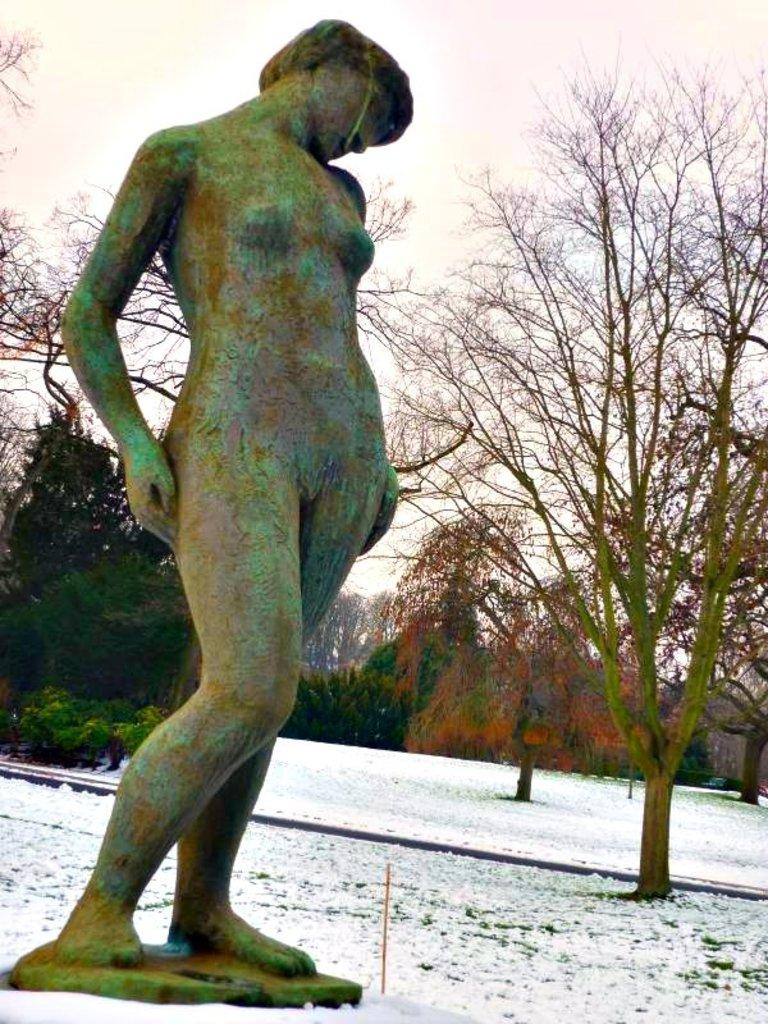What is located on the left side of the image? There is a statue on the left side of the image. What is covering the ground in the image? There is snow at the bottom of the image. What can be seen in the distance in the image? There are trees in the background of the image. Where is the store located in the image? There is no store present in the image. What type of blade is being used to cut the trees in the background? There is no blade or tree-cutting activity depicted in the image. 